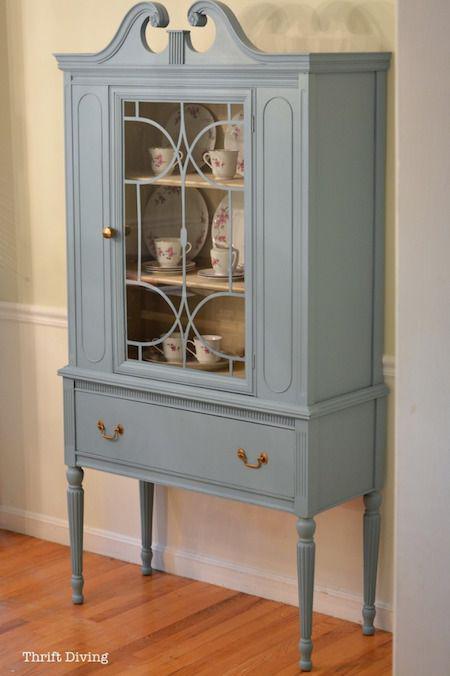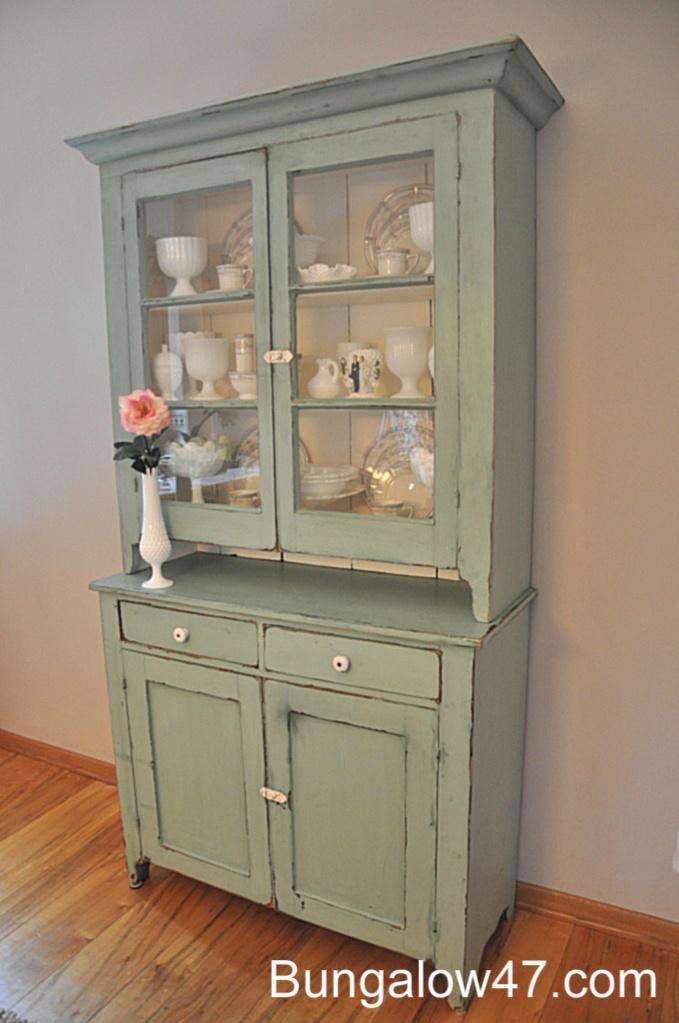The first image is the image on the left, the second image is the image on the right. Given the left and right images, does the statement "A wooden cabinet in one image stands of long spindle legs, and has solid panels on each side of a wide glass door, and a full-width drawer with two pulls." hold true? Answer yes or no. Yes. The first image is the image on the left, the second image is the image on the right. Evaluate the accuracy of this statement regarding the images: "The cabinet in the right image is light green.". Is it true? Answer yes or no. Yes. 